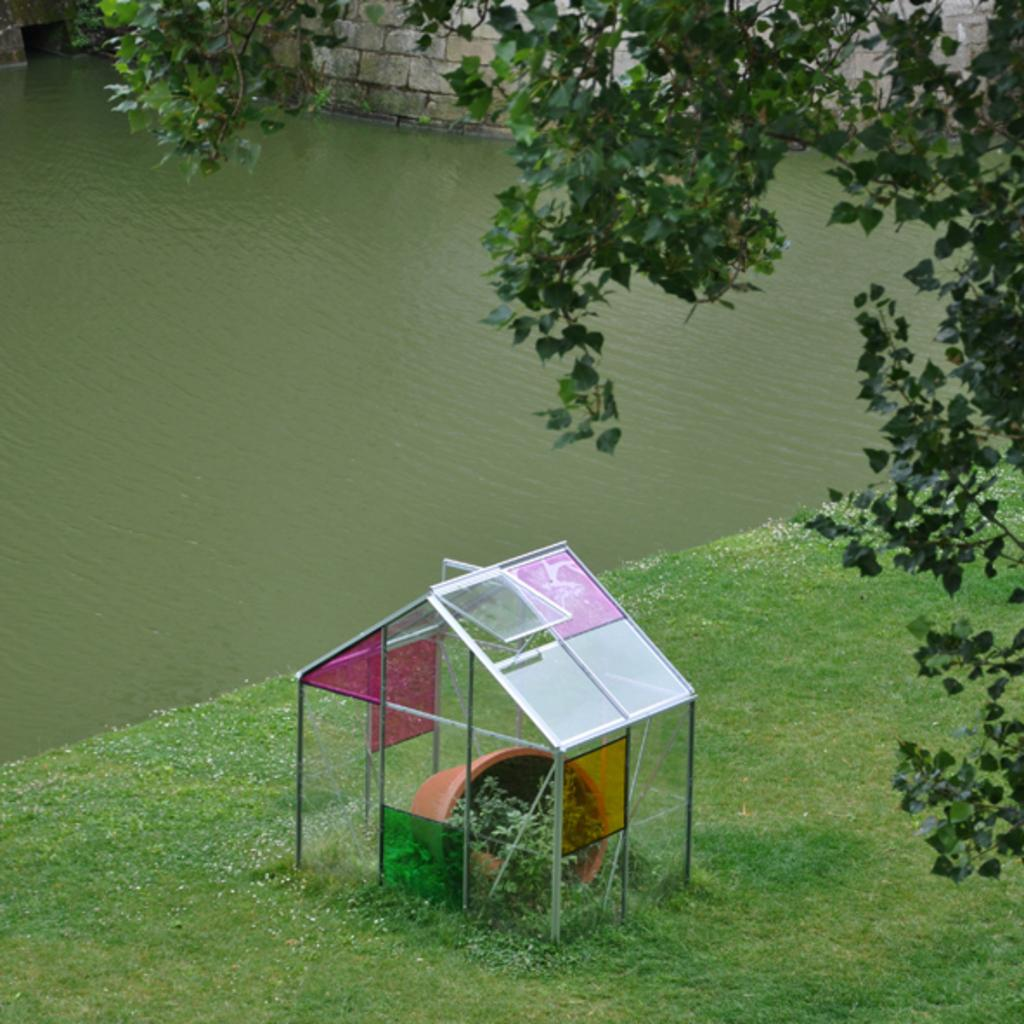What is the main subject in the center of the image? There is a house, a flower pot, and a plant in the center of the image. What type of vegetation is present in the center of the image? There is a plant in the center of the image. What can be seen at the bottom of the image? There is grass at the bottom of the image. What is visible in the background of the image? There is a lake and a wall in the background of the image. What other natural element is present on the right side of the image? There is a tree on the right side of the image. What type of store can be seen in the image? There is no store present in the image. What material is the tree made of in the image? The tree is made of natural materials, such as wood and leaves, and is not made of metal. 